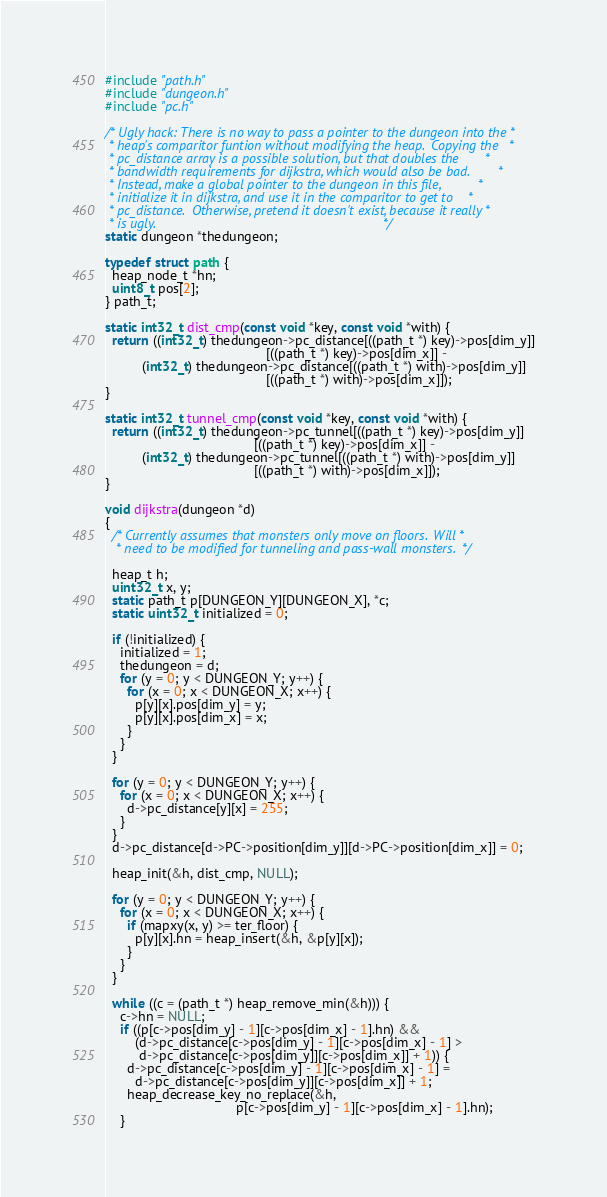Convert code to text. <code><loc_0><loc_0><loc_500><loc_500><_C++_>#include "path.h"
#include "dungeon.h"
#include "pc.h"

/* Ugly hack: There is no way to pass a pointer to the dungeon into the *
 * heap's comparitor funtion without modifying the heap.  Copying the   *
 * pc_distance array is a possible solution, but that doubles the       *
 * bandwidth requirements for dijkstra, which would also be bad.        *
 * Instead, make a global pointer to the dungeon in this file,          *
 * initialize it in dijkstra, and use it in the comparitor to get to    *
 * pc_distance.  Otherwise, pretend it doesn't exist, because it really *
 * is ugly.                                                             */
static dungeon *thedungeon;

typedef struct path {
  heap_node_t *hn;
  uint8_t pos[2];
} path_t;

static int32_t dist_cmp(const void *key, const void *with) {
  return ((int32_t) thedungeon->pc_distance[((path_t *) key)->pos[dim_y]]
                                           [((path_t *) key)->pos[dim_x]] -
          (int32_t) thedungeon->pc_distance[((path_t *) with)->pos[dim_y]]
                                           [((path_t *) with)->pos[dim_x]]);
}

static int32_t tunnel_cmp(const void *key, const void *with) {
  return ((int32_t) thedungeon->pc_tunnel[((path_t *) key)->pos[dim_y]]
                                        [((path_t *) key)->pos[dim_x]] -
          (int32_t) thedungeon->pc_tunnel[((path_t *) with)->pos[dim_y]]
                                        [((path_t *) with)->pos[dim_x]]);
}

void dijkstra(dungeon *d)
{
  /* Currently assumes that monsters only move on floors.  Will *
   * need to be modified for tunneling and pass-wall monsters.  */

  heap_t h;
  uint32_t x, y;
  static path_t p[DUNGEON_Y][DUNGEON_X], *c;
  static uint32_t initialized = 0;

  if (!initialized) {
    initialized = 1;
    thedungeon = d;
    for (y = 0; y < DUNGEON_Y; y++) {
      for (x = 0; x < DUNGEON_X; x++) {
        p[y][x].pos[dim_y] = y;
        p[y][x].pos[dim_x] = x;
      }
    }
  }

  for (y = 0; y < DUNGEON_Y; y++) {
    for (x = 0; x < DUNGEON_X; x++) {
      d->pc_distance[y][x] = 255;
    }
  }
  d->pc_distance[d->PC->position[dim_y]][d->PC->position[dim_x]] = 0;

  heap_init(&h, dist_cmp, NULL);

  for (y = 0; y < DUNGEON_Y; y++) {
    for (x = 0; x < DUNGEON_X; x++) {
      if (mapxy(x, y) >= ter_floor) {
        p[y][x].hn = heap_insert(&h, &p[y][x]);
      }
    }
  }

  while ((c = (path_t *) heap_remove_min(&h))) {
    c->hn = NULL;
    if ((p[c->pos[dim_y] - 1][c->pos[dim_x] - 1].hn) &&
        (d->pc_distance[c->pos[dim_y] - 1][c->pos[dim_x] - 1] >
         d->pc_distance[c->pos[dim_y]][c->pos[dim_x]] + 1)) {
      d->pc_distance[c->pos[dim_y] - 1][c->pos[dim_x] - 1] =
        d->pc_distance[c->pos[dim_y]][c->pos[dim_x]] + 1;
      heap_decrease_key_no_replace(&h,
                                   p[c->pos[dim_y] - 1][c->pos[dim_x] - 1].hn);
    }</code> 